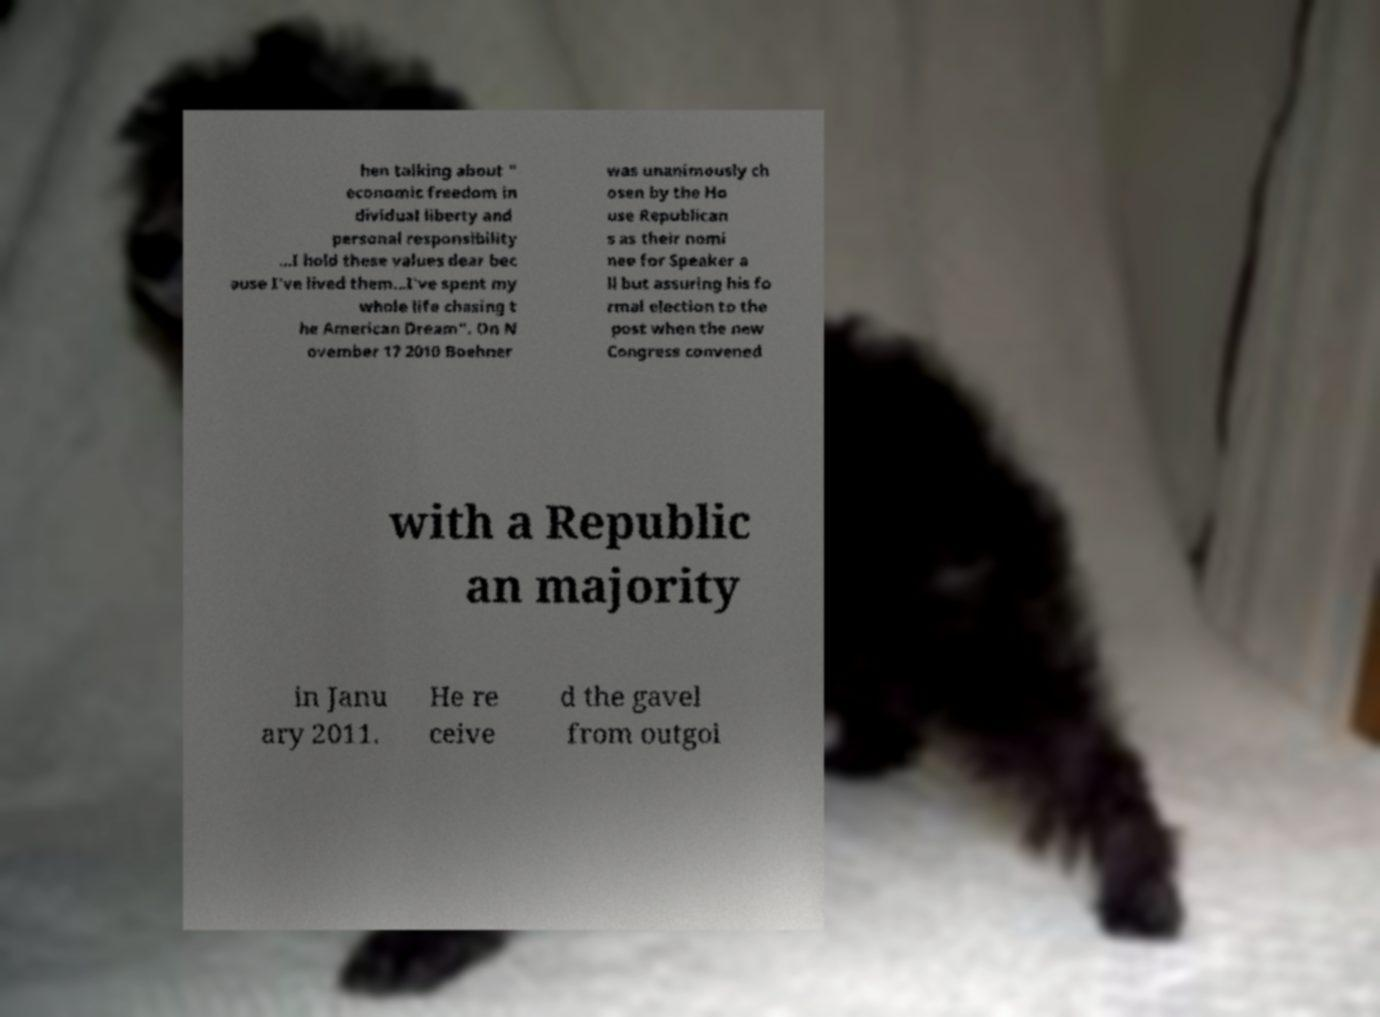What messages or text are displayed in this image? I need them in a readable, typed format. hen talking about " economic freedom in dividual liberty and personal responsibility ...I hold these values dear bec ause I've lived them...I've spent my whole life chasing t he American Dream". On N ovember 17 2010 Boehner was unanimously ch osen by the Ho use Republican s as their nomi nee for Speaker a ll but assuring his fo rmal election to the post when the new Congress convened with a Republic an majority in Janu ary 2011. He re ceive d the gavel from outgoi 